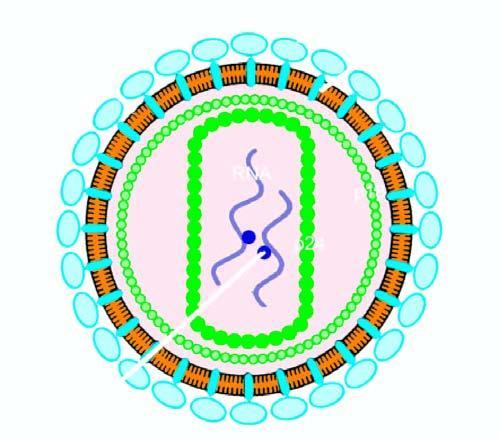what is studded with 2 viral glycoproteins, gp120 and gp41, in the positions shown?
Answer the question using a single word or phrase. Bilayer lipid membrane 